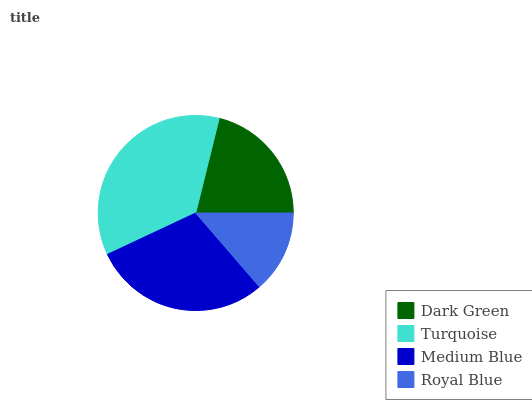Is Royal Blue the minimum?
Answer yes or no. Yes. Is Turquoise the maximum?
Answer yes or no. Yes. Is Medium Blue the minimum?
Answer yes or no. No. Is Medium Blue the maximum?
Answer yes or no. No. Is Turquoise greater than Medium Blue?
Answer yes or no. Yes. Is Medium Blue less than Turquoise?
Answer yes or no. Yes. Is Medium Blue greater than Turquoise?
Answer yes or no. No. Is Turquoise less than Medium Blue?
Answer yes or no. No. Is Medium Blue the high median?
Answer yes or no. Yes. Is Dark Green the low median?
Answer yes or no. Yes. Is Turquoise the high median?
Answer yes or no. No. Is Turquoise the low median?
Answer yes or no. No. 